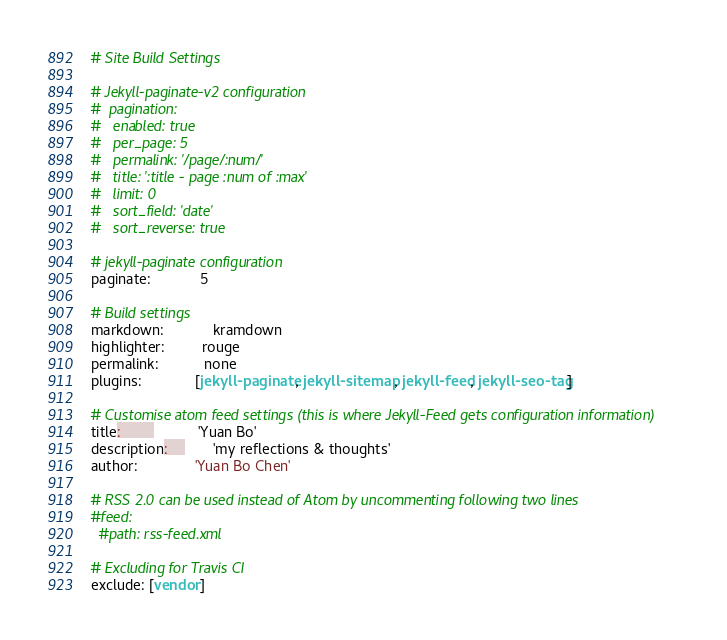<code> <loc_0><loc_0><loc_500><loc_500><_YAML_># Site Build Settings

# Jekyll-paginate-v2 configuration
#  pagination:
#   enabled: true
#   per_page: 5
#   permalink: '/page/:num/'
#   title: ':title - page :num of :max'
#   limit: 0
#   sort_field: 'date'
#   sort_reverse: true

# jekyll-paginate configuration
paginate:            5

# Build settings
markdown:            kramdown
highlighter:         rouge
permalink:           none
plugins:             [jekyll-paginate, jekyll-sitemap, jekyll-feed, jekyll-seo-tag]

# Customise atom feed settings (this is where Jekyll-Feed gets configuration information)
title:		           'Yuan Bo'
description:	       'my reflections & thoughts'
author:              'Yuan Bo Chen'

# RSS 2.0 can be used instead of Atom by uncommenting following two lines
#feed:
  #path: rss-feed.xml

# Excluding for Travis CI
exclude: [vendor]</code> 